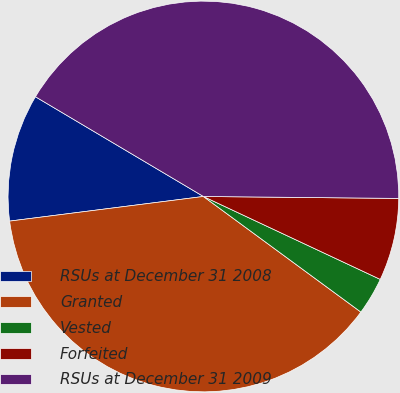<chart> <loc_0><loc_0><loc_500><loc_500><pie_chart><fcel>RSUs at December 31 2008<fcel>Granted<fcel>Vested<fcel>Forfeited<fcel>RSUs at December 31 2009<nl><fcel>10.54%<fcel>37.91%<fcel>3.1%<fcel>6.82%<fcel>41.63%<nl></chart> 